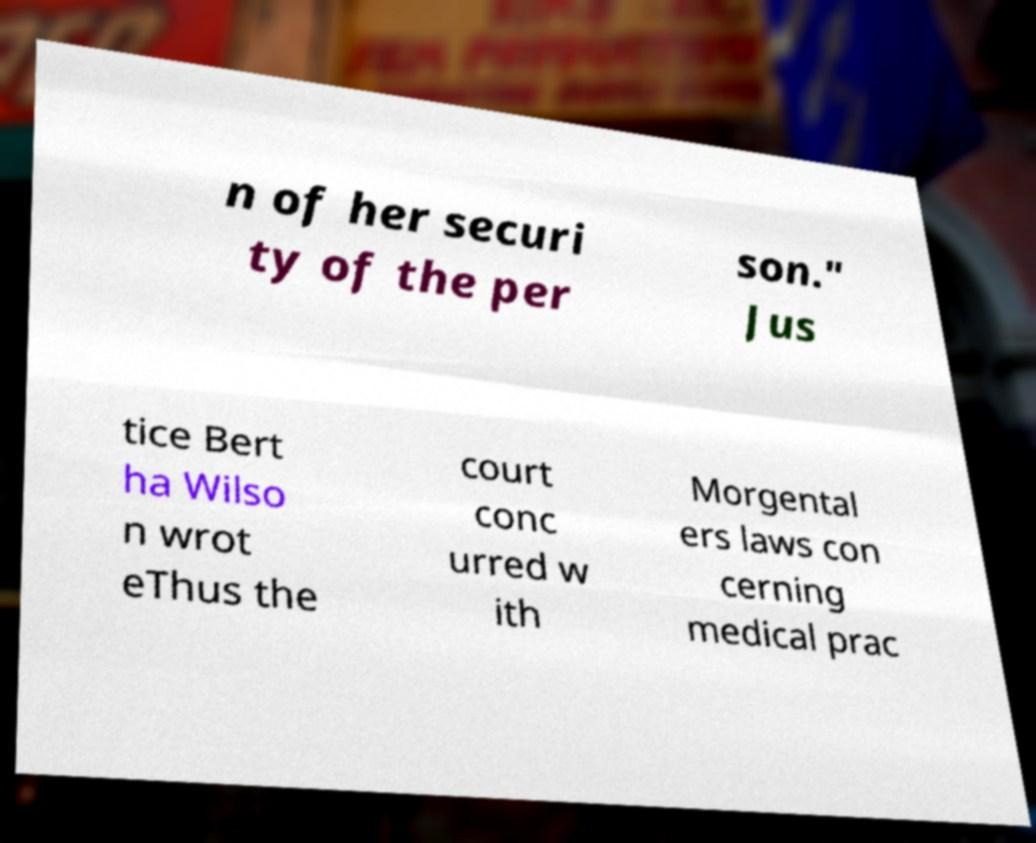I need the written content from this picture converted into text. Can you do that? n of her securi ty of the per son." Jus tice Bert ha Wilso n wrot eThus the court conc urred w ith Morgental ers laws con cerning medical prac 